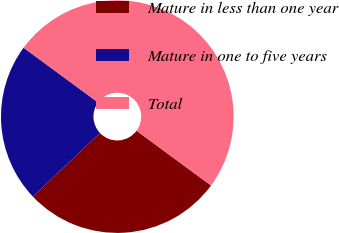Convert chart to OTSL. <chart><loc_0><loc_0><loc_500><loc_500><pie_chart><fcel>Mature in less than one year<fcel>Mature in one to five years<fcel>Total<nl><fcel>27.84%<fcel>22.16%<fcel>50.0%<nl></chart> 